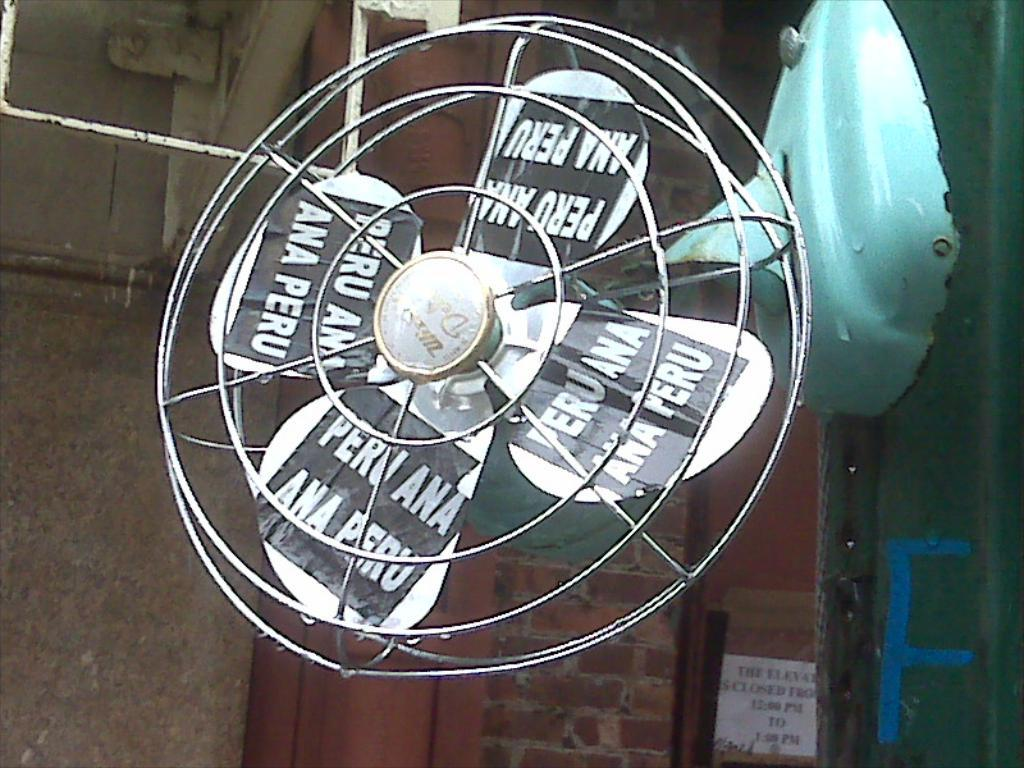What is the main object in the center of the image? There is a table fan in the center of the image. What can be seen in the background of the image? There is a wall in the background of the image. How many sticks are being used by the crowd in the image? There is no crowd present in the image, and therefore no sticks being used. Is there a bike visible in the image? No, there is no bike visible in the image. 